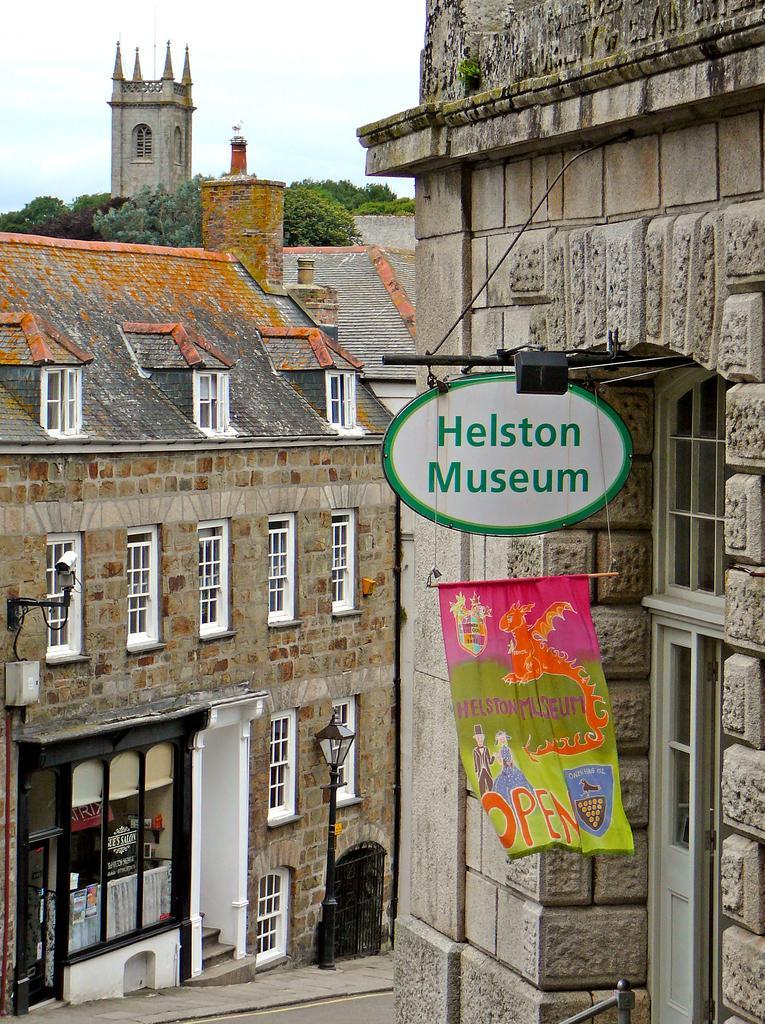Could you give a brief overview of what you see in this image? In this image we can see buildings, flag, board, light, street lights, road, trees, castle and sky. 